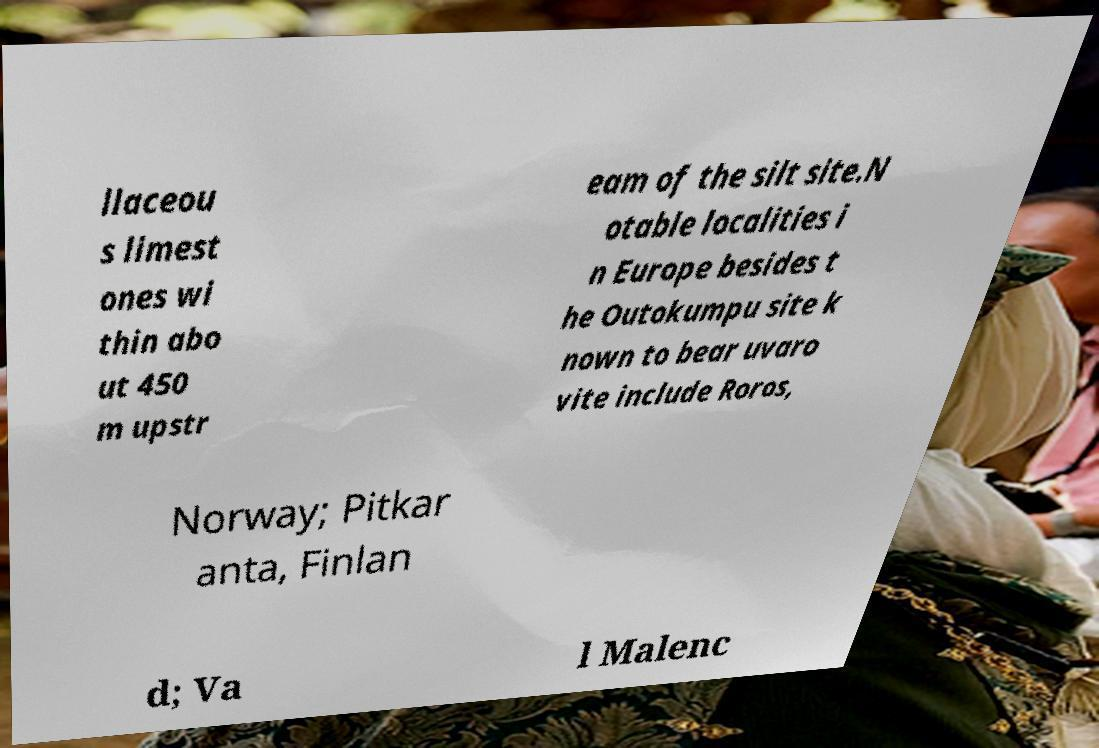There's text embedded in this image that I need extracted. Can you transcribe it verbatim? llaceou s limest ones wi thin abo ut 450 m upstr eam of the silt site.N otable localities i n Europe besides t he Outokumpu site k nown to bear uvaro vite include Roros, Norway; Pitkar anta, Finlan d; Va l Malenc 